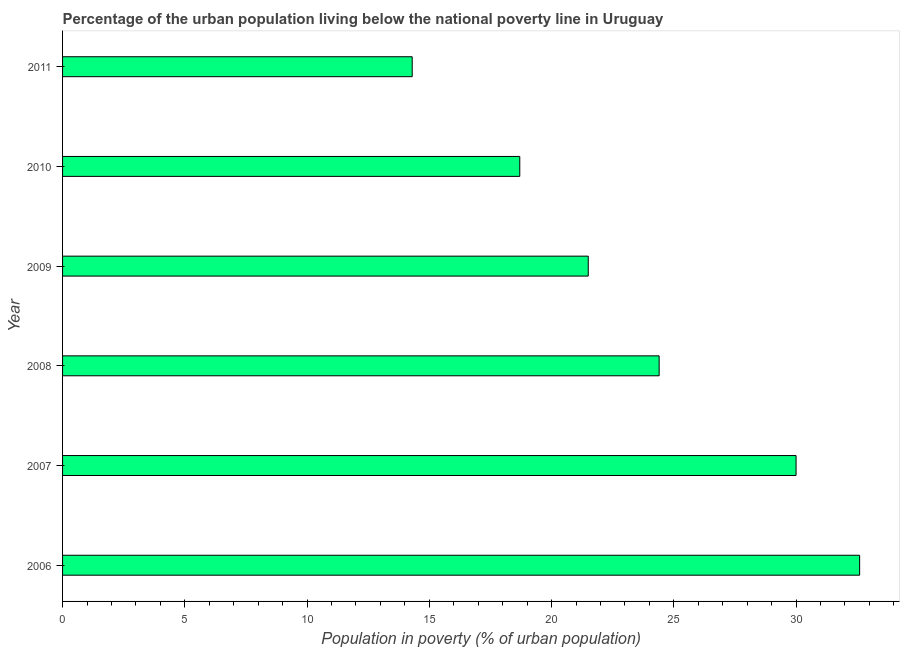Does the graph contain any zero values?
Your answer should be very brief. No. Does the graph contain grids?
Your answer should be very brief. No. What is the title of the graph?
Provide a succinct answer. Percentage of the urban population living below the national poverty line in Uruguay. What is the label or title of the X-axis?
Keep it short and to the point. Population in poverty (% of urban population). What is the label or title of the Y-axis?
Make the answer very short. Year. What is the percentage of urban population living below poverty line in 2010?
Give a very brief answer. 18.7. Across all years, what is the maximum percentage of urban population living below poverty line?
Offer a terse response. 32.6. Across all years, what is the minimum percentage of urban population living below poverty line?
Offer a terse response. 14.3. What is the sum of the percentage of urban population living below poverty line?
Your answer should be compact. 141.5. What is the difference between the percentage of urban population living below poverty line in 2007 and 2009?
Ensure brevity in your answer.  8.5. What is the average percentage of urban population living below poverty line per year?
Provide a succinct answer. 23.58. What is the median percentage of urban population living below poverty line?
Provide a succinct answer. 22.95. What is the ratio of the percentage of urban population living below poverty line in 2009 to that in 2010?
Your answer should be compact. 1.15. Is the percentage of urban population living below poverty line in 2007 less than that in 2009?
Make the answer very short. No. What is the difference between the highest and the second highest percentage of urban population living below poverty line?
Offer a terse response. 2.6. What is the difference between the highest and the lowest percentage of urban population living below poverty line?
Give a very brief answer. 18.3. How many years are there in the graph?
Offer a very short reply. 6. What is the Population in poverty (% of urban population) in 2006?
Provide a short and direct response. 32.6. What is the Population in poverty (% of urban population) in 2008?
Offer a terse response. 24.4. What is the Population in poverty (% of urban population) of 2009?
Keep it short and to the point. 21.5. What is the Population in poverty (% of urban population) of 2010?
Your answer should be very brief. 18.7. What is the Population in poverty (% of urban population) in 2011?
Keep it short and to the point. 14.3. What is the difference between the Population in poverty (% of urban population) in 2006 and 2009?
Give a very brief answer. 11.1. What is the difference between the Population in poverty (% of urban population) in 2006 and 2011?
Give a very brief answer. 18.3. What is the difference between the Population in poverty (% of urban population) in 2007 and 2009?
Keep it short and to the point. 8.5. What is the difference between the Population in poverty (% of urban population) in 2008 and 2010?
Your response must be concise. 5.7. What is the difference between the Population in poverty (% of urban population) in 2008 and 2011?
Provide a short and direct response. 10.1. What is the difference between the Population in poverty (% of urban population) in 2009 and 2010?
Your answer should be very brief. 2.8. What is the ratio of the Population in poverty (% of urban population) in 2006 to that in 2007?
Give a very brief answer. 1.09. What is the ratio of the Population in poverty (% of urban population) in 2006 to that in 2008?
Make the answer very short. 1.34. What is the ratio of the Population in poverty (% of urban population) in 2006 to that in 2009?
Your answer should be compact. 1.52. What is the ratio of the Population in poverty (% of urban population) in 2006 to that in 2010?
Offer a terse response. 1.74. What is the ratio of the Population in poverty (% of urban population) in 2006 to that in 2011?
Provide a short and direct response. 2.28. What is the ratio of the Population in poverty (% of urban population) in 2007 to that in 2008?
Offer a terse response. 1.23. What is the ratio of the Population in poverty (% of urban population) in 2007 to that in 2009?
Your answer should be compact. 1.4. What is the ratio of the Population in poverty (% of urban population) in 2007 to that in 2010?
Ensure brevity in your answer.  1.6. What is the ratio of the Population in poverty (% of urban population) in 2007 to that in 2011?
Keep it short and to the point. 2.1. What is the ratio of the Population in poverty (% of urban population) in 2008 to that in 2009?
Keep it short and to the point. 1.14. What is the ratio of the Population in poverty (% of urban population) in 2008 to that in 2010?
Your response must be concise. 1.3. What is the ratio of the Population in poverty (% of urban population) in 2008 to that in 2011?
Your response must be concise. 1.71. What is the ratio of the Population in poverty (% of urban population) in 2009 to that in 2010?
Make the answer very short. 1.15. What is the ratio of the Population in poverty (% of urban population) in 2009 to that in 2011?
Give a very brief answer. 1.5. What is the ratio of the Population in poverty (% of urban population) in 2010 to that in 2011?
Offer a terse response. 1.31. 